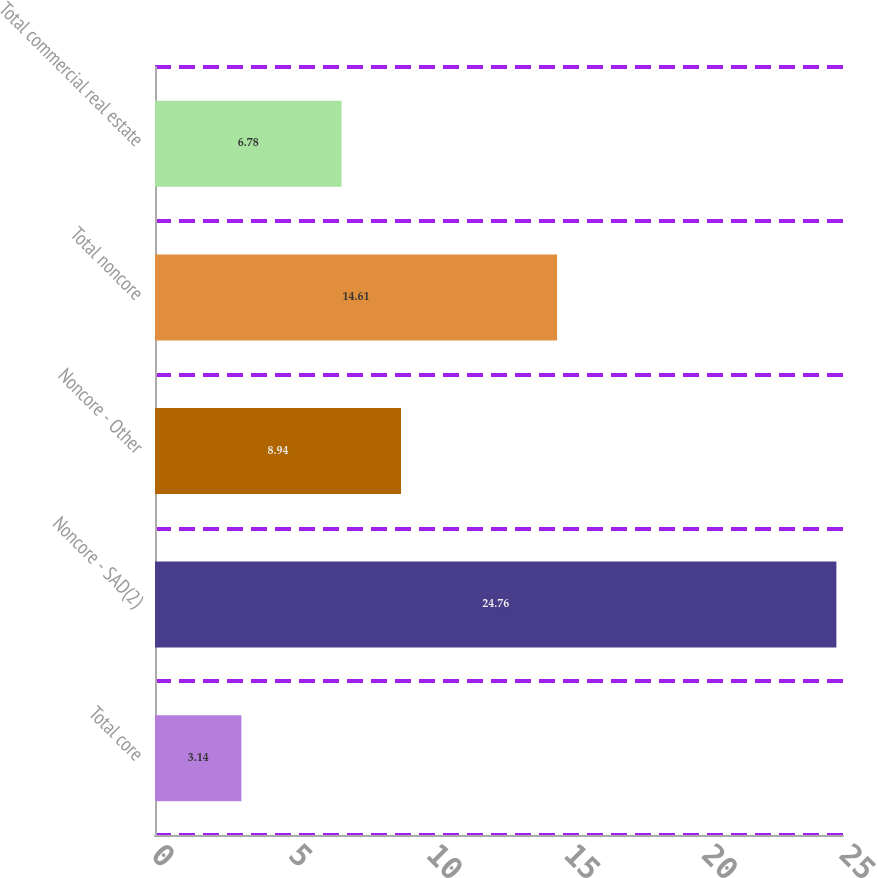Convert chart to OTSL. <chart><loc_0><loc_0><loc_500><loc_500><bar_chart><fcel>Total core<fcel>Noncore - SAD(2)<fcel>Noncore - Other<fcel>Total noncore<fcel>Total commercial real estate<nl><fcel>3.14<fcel>24.76<fcel>8.94<fcel>14.61<fcel>6.78<nl></chart> 